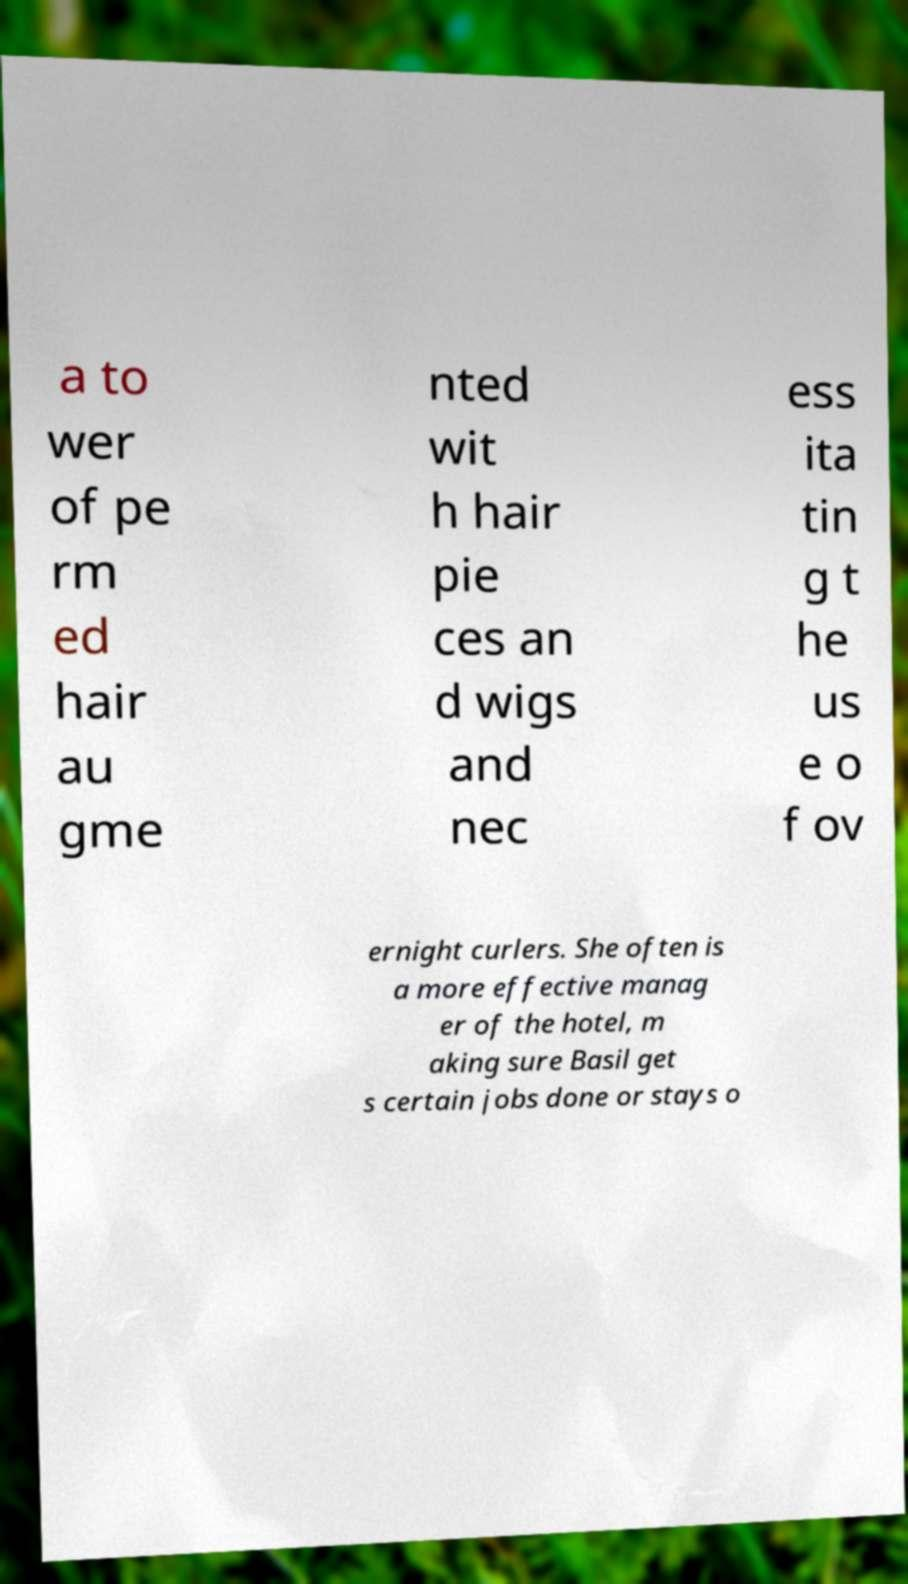For documentation purposes, I need the text within this image transcribed. Could you provide that? a to wer of pe rm ed hair au gme nted wit h hair pie ces an d wigs and nec ess ita tin g t he us e o f ov ernight curlers. She often is a more effective manag er of the hotel, m aking sure Basil get s certain jobs done or stays o 